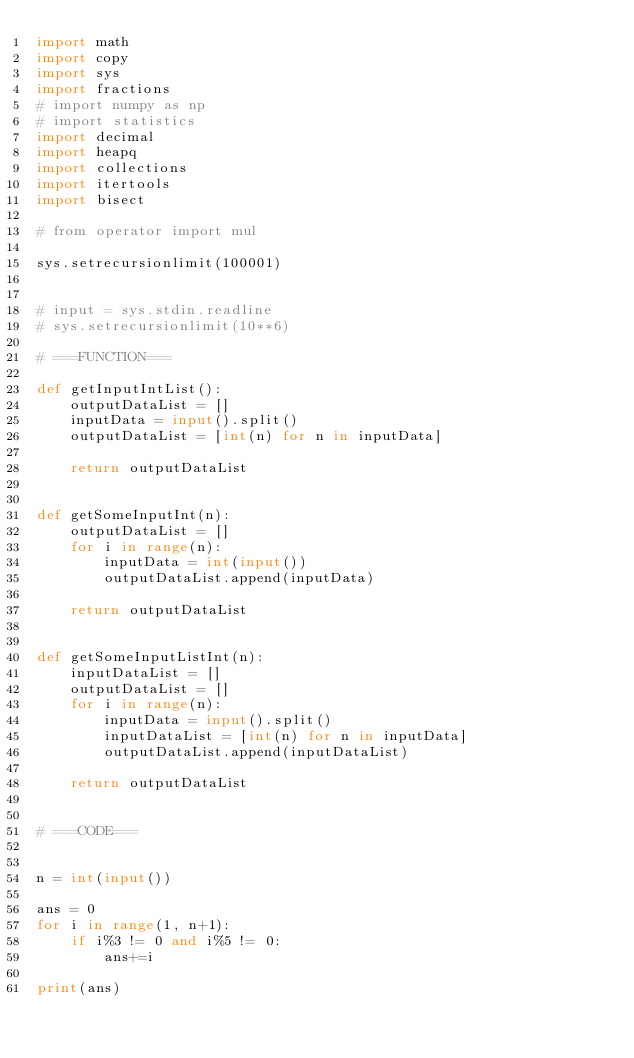Convert code to text. <code><loc_0><loc_0><loc_500><loc_500><_Python_>import math
import copy
import sys
import fractions
# import numpy as np
# import statistics
import decimal
import heapq
import collections
import itertools
import bisect

# from operator import mul

sys.setrecursionlimit(100001)


# input = sys.stdin.readline
# sys.setrecursionlimit(10**6)

# ===FUNCTION===

def getInputIntList():
    outputDataList = []
    inputData = input().split()
    outputDataList = [int(n) for n in inputData]

    return outputDataList


def getSomeInputInt(n):
    outputDataList = []
    for i in range(n):
        inputData = int(input())
        outputDataList.append(inputData)

    return outputDataList


def getSomeInputListInt(n):
    inputDataList = []
    outputDataList = []
    for i in range(n):
        inputData = input().split()
        inputDataList = [int(n) for n in inputData]
        outputDataList.append(inputDataList)

    return outputDataList


# ===CODE===


n = int(input())

ans = 0
for i in range(1, n+1):
    if i%3 != 0 and i%5 != 0:
        ans+=i

print(ans)
</code> 